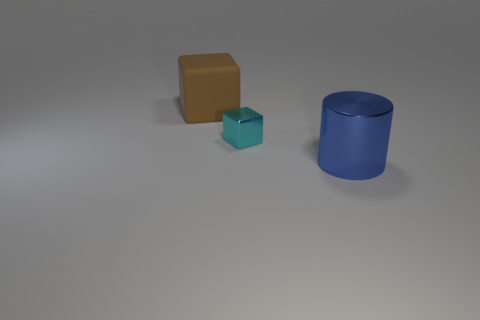Add 2 blue objects. How many objects exist? 5 Subtract all cubes. How many objects are left? 1 Subtract all small red matte cylinders. Subtract all large cylinders. How many objects are left? 2 Add 3 cyan objects. How many cyan objects are left? 4 Add 3 small cyan objects. How many small cyan objects exist? 4 Subtract 1 brown blocks. How many objects are left? 2 